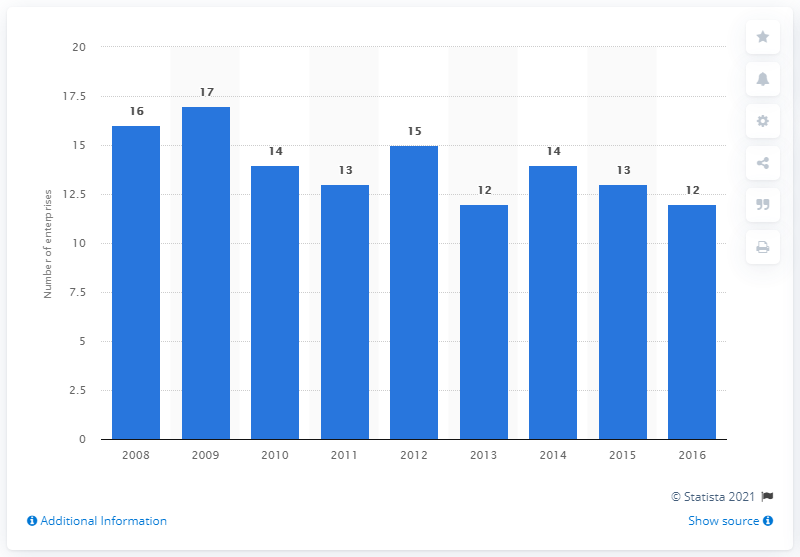Identify some key points in this picture. In 2016, there were 12 enterprises in Denmark that manufactured electric domestic appliances. 